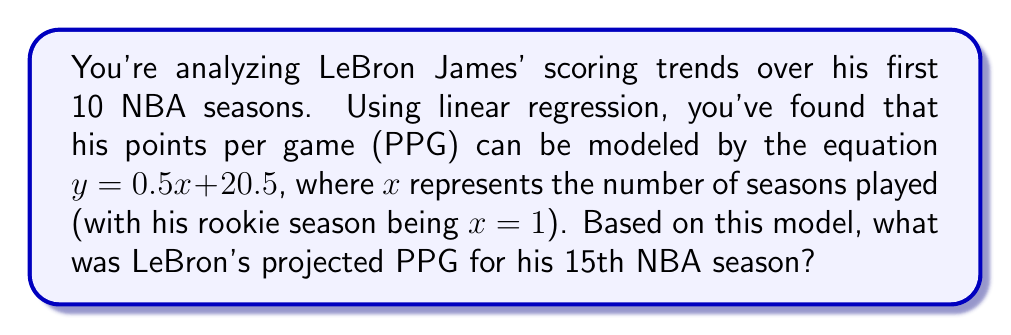Teach me how to tackle this problem. To solve this problem, we'll follow these steps:

1) We're given the linear regression equation:
   $y = 0.5x + 20.5$
   Where $y$ is the projected PPG and $x$ is the number of seasons played.

2) We need to find $y$ when $x = 15$ (15th NBA season).

3) Let's substitute $x = 15$ into the equation:
   $y = 0.5(15) + 20.5$

4) Simplify:
   $y = 7.5 + 20.5$

5) Calculate the final result:
   $y = 28$

Therefore, based on this linear regression model, LeBron's projected PPG for his 15th NBA season would be 28 points per game.
Answer: 28 PPG 